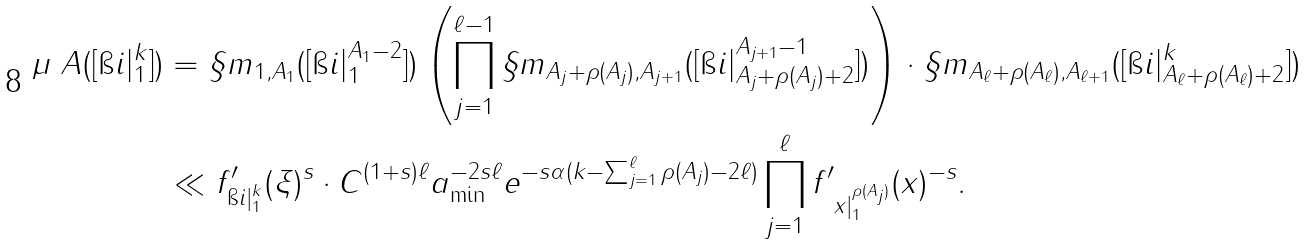Convert formula to latex. <formula><loc_0><loc_0><loc_500><loc_500>\mu _ { \ } A ( [ \i i | _ { 1 } ^ { k } ] ) & = \S m _ { 1 , A _ { 1 } } ( [ \i i | _ { 1 } ^ { A _ { 1 } - 2 } ] ) \left ( \prod _ { j = 1 } ^ { \ell - 1 } \S m _ { A _ { j } + \rho ( A _ { j } ) , A _ { j + 1 } } ( [ \i i | _ { A _ { j } + \rho ( A _ { j } ) + 2 } ^ { A _ { j + 1 } - 1 } ] ) \right ) \cdot \S m _ { A _ { \ell } + \rho ( A _ { \ell } ) , A _ { \ell + 1 } } ( [ \i i | _ { A _ { \ell } + \rho ( A _ { \ell } ) + 2 } ^ { k } ] ) \\ & \ll \| f _ { \i i | _ { 1 } ^ { k } } ^ { \prime } ( \xi ) \| ^ { s } \cdot C ^ { ( 1 + s ) \ell } a _ { \min } ^ { - 2 s \ell } e ^ { - s \alpha ( k - \sum _ { j = 1 } ^ { \ell } \rho ( A _ { j } ) - 2 \ell ) } \prod _ { j = 1 } ^ { \ell } \| f _ { \ x | _ { 1 } ^ { \rho ( A _ { j } ) } } ^ { \prime } ( x ) \| ^ { - s } .</formula> 